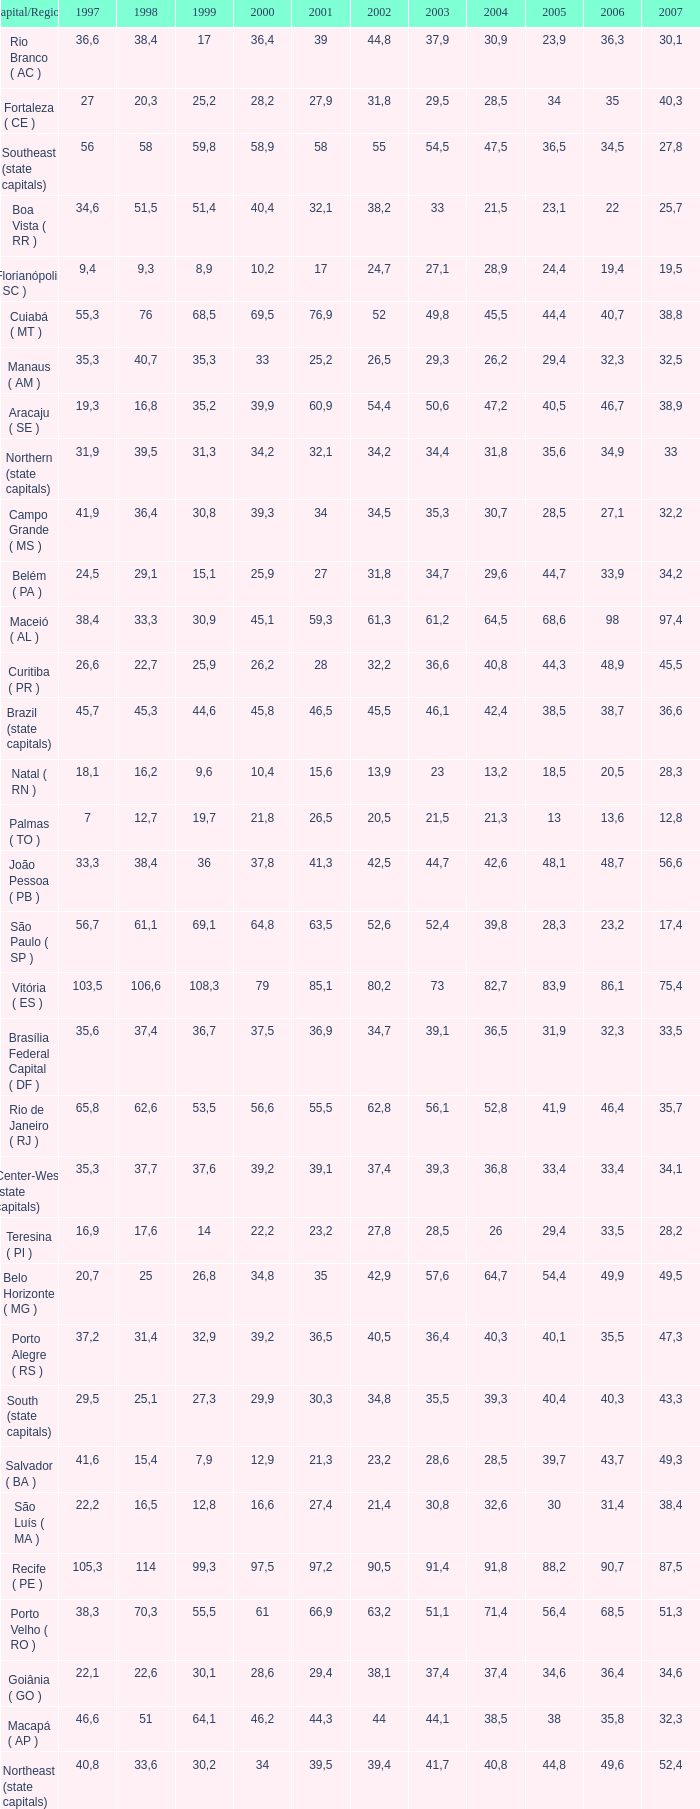What is the average 2000 that has a 1997 greater than 34,6, a 2006 greater than 38,7, and a 2998 less than 76? 41.92. 